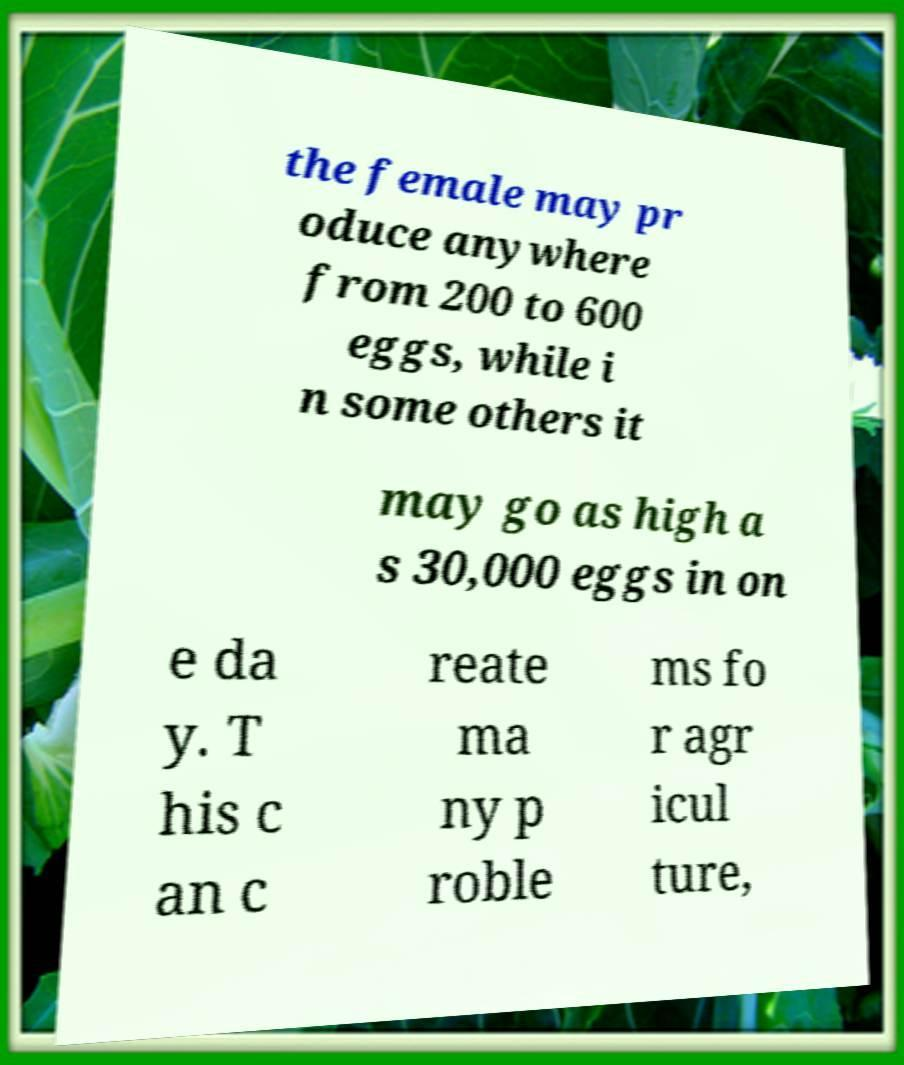Could you assist in decoding the text presented in this image and type it out clearly? the female may pr oduce anywhere from 200 to 600 eggs, while i n some others it may go as high a s 30,000 eggs in on e da y. T his c an c reate ma ny p roble ms fo r agr icul ture, 